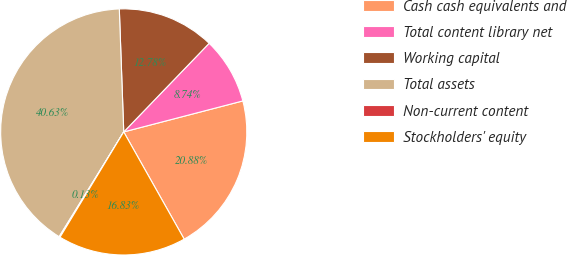Convert chart. <chart><loc_0><loc_0><loc_500><loc_500><pie_chart><fcel>Cash cash equivalents and<fcel>Total content library net<fcel>Working capital<fcel>Total assets<fcel>Non-current content<fcel>Stockholders' equity<nl><fcel>20.88%<fcel>8.74%<fcel>12.78%<fcel>40.63%<fcel>0.13%<fcel>16.83%<nl></chart> 